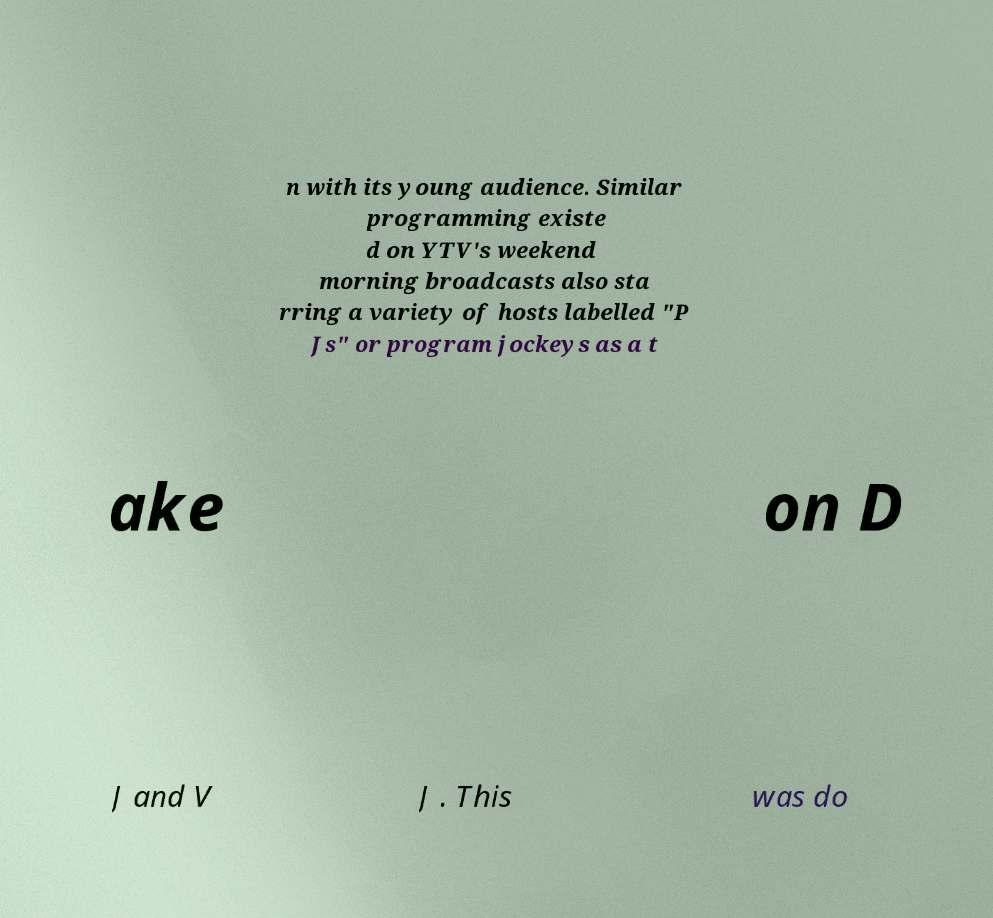There's text embedded in this image that I need extracted. Can you transcribe it verbatim? n with its young audience. Similar programming existe d on YTV's weekend morning broadcasts also sta rring a variety of hosts labelled "P Js" or program jockeys as a t ake on D J and V J . This was do 